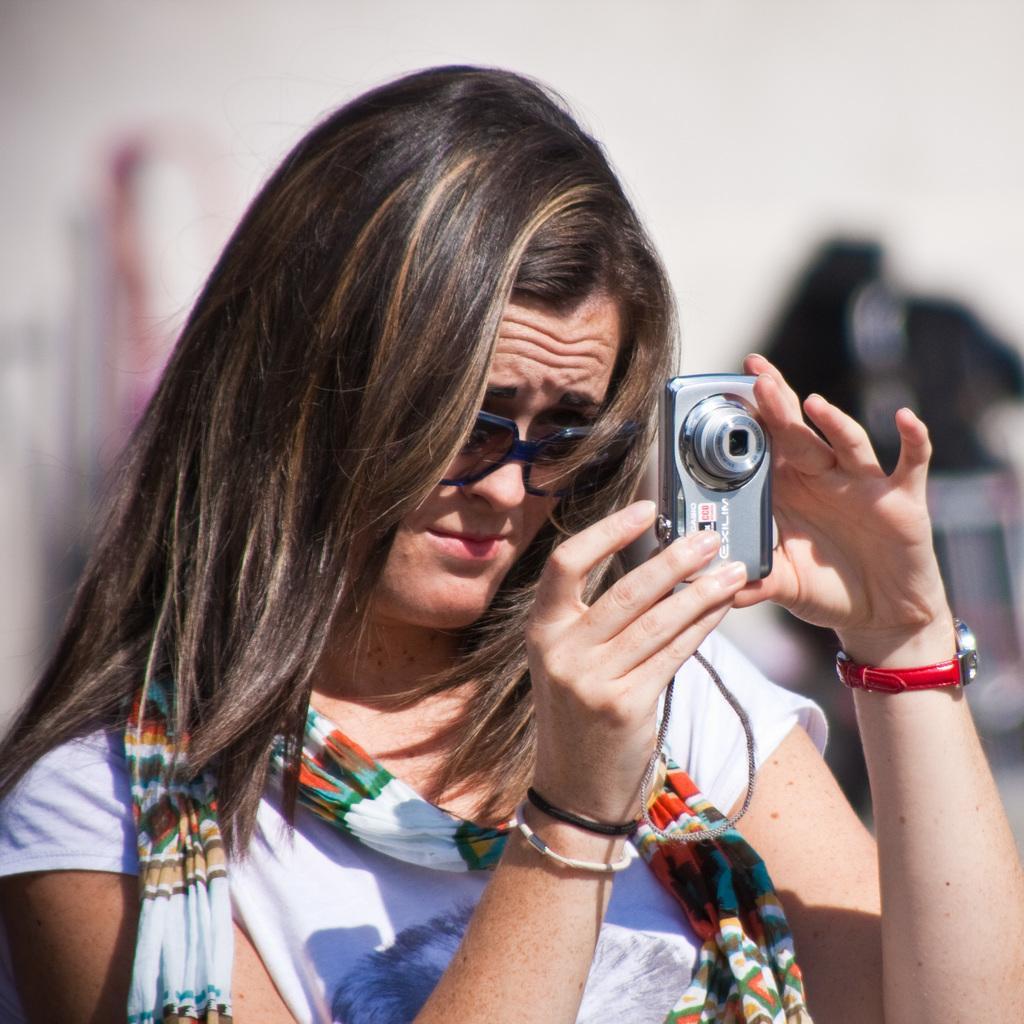How would you summarize this image in a sentence or two? In the image we can see there is a woman who is standing and holding camera in her hand. 